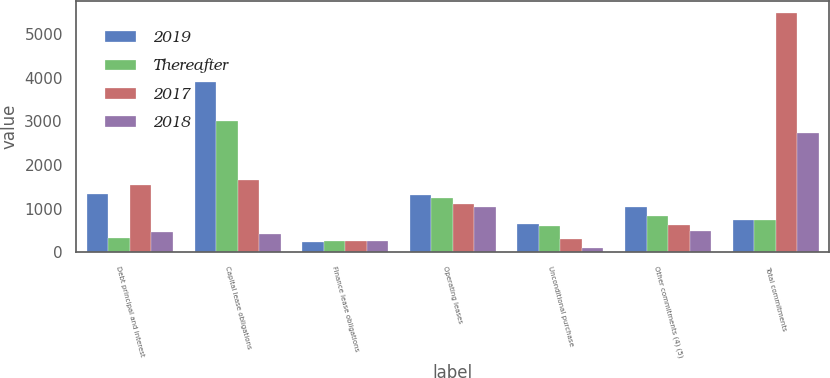Convert chart to OTSL. <chart><loc_0><loc_0><loc_500><loc_500><stacked_bar_chart><ecel><fcel>Debt principal and interest<fcel>Capital lease obligations<fcel>Finance lease obligations<fcel>Operating leases<fcel>Unconditional purchase<fcel>Other commitments (4) (5)<fcel>Total commitments<nl><fcel>2019<fcel>1343<fcel>3910<fcel>234<fcel>1317<fcel>655<fcel>1025<fcel>739.5<nl><fcel>Thereafter<fcel>312<fcel>3008<fcel>244<fcel>1231<fcel>590<fcel>824<fcel>739.5<nl><fcel>2017<fcel>1551<fcel>1662<fcel>247<fcel>1106<fcel>303<fcel>621<fcel>5490<nl><fcel>2018<fcel>463<fcel>411<fcel>250<fcel>1030<fcel>96<fcel>493<fcel>2743<nl></chart> 